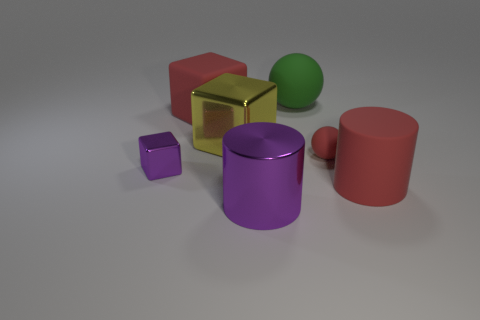Add 1 big green matte spheres. How many objects exist? 8 Subtract all cylinders. How many objects are left? 5 Add 6 tiny cyan matte objects. How many tiny cyan matte objects exist? 6 Subtract 0 gray spheres. How many objects are left? 7 Subtract all big green spheres. Subtract all tiny red rubber objects. How many objects are left? 5 Add 5 red objects. How many red objects are left? 8 